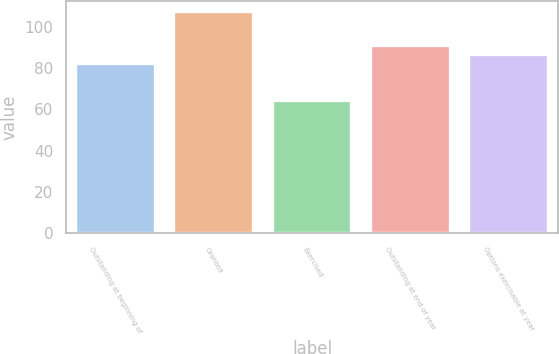Convert chart to OTSL. <chart><loc_0><loc_0><loc_500><loc_500><bar_chart><fcel>Outstanding at beginning of<fcel>Granted<fcel>Exercised<fcel>Outstanding at end of year<fcel>Options exercisable at year<nl><fcel>82.08<fcel>107.21<fcel>63.97<fcel>90.72<fcel>86.4<nl></chart> 